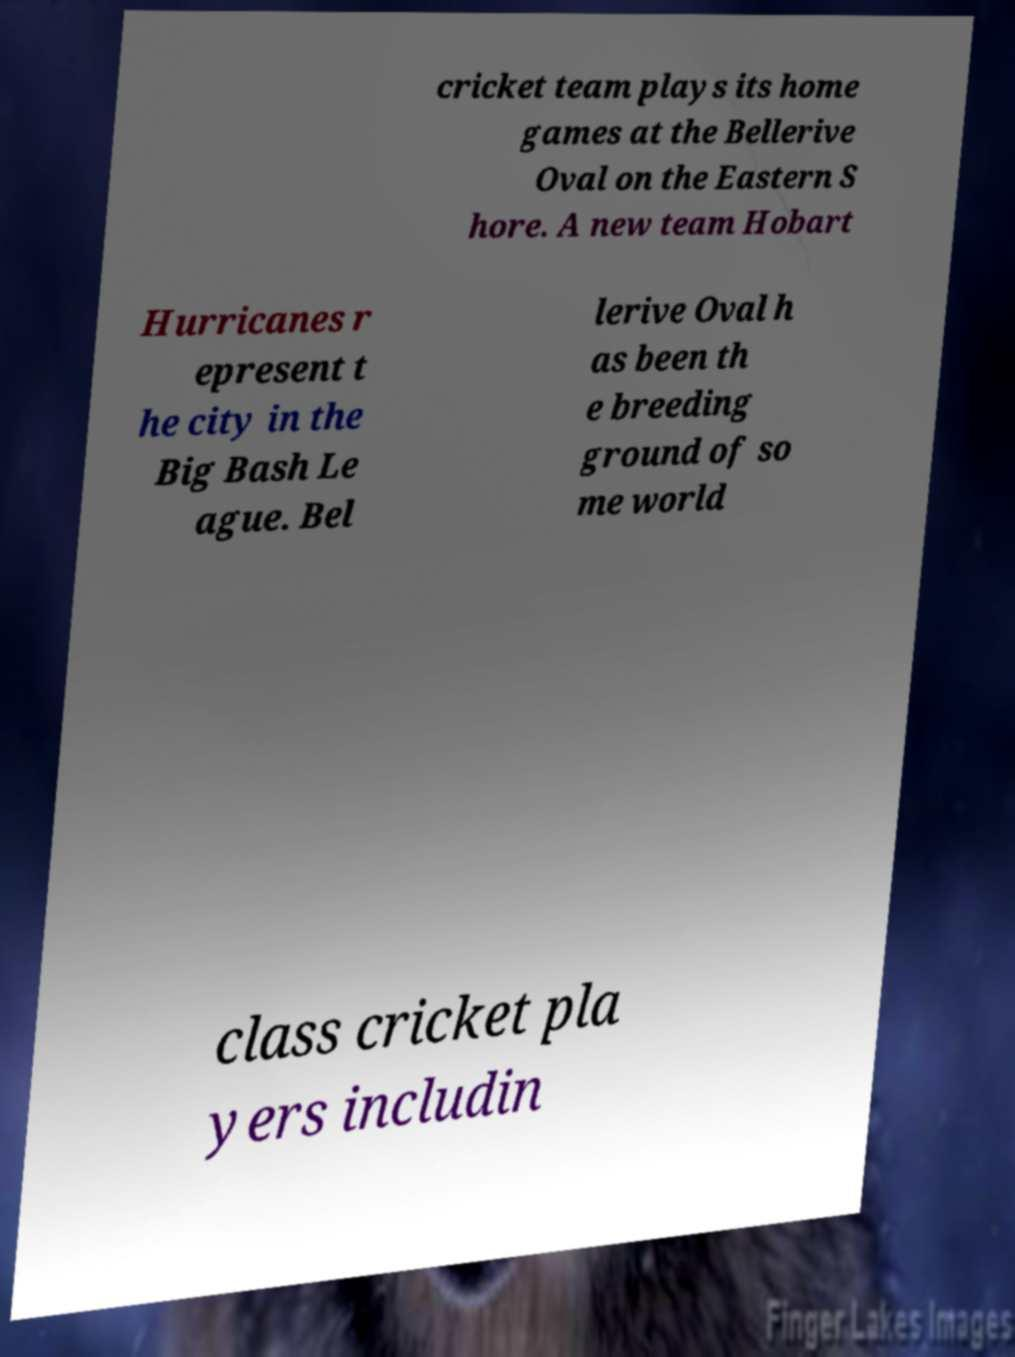Can you accurately transcribe the text from the provided image for me? cricket team plays its home games at the Bellerive Oval on the Eastern S hore. A new team Hobart Hurricanes r epresent t he city in the Big Bash Le ague. Bel lerive Oval h as been th e breeding ground of so me world class cricket pla yers includin 